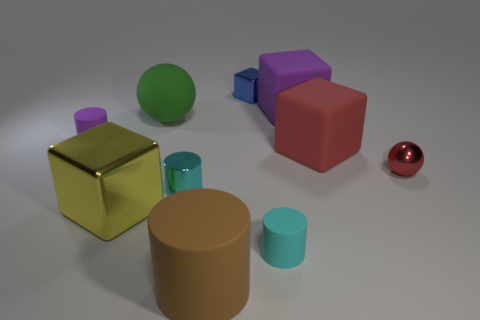What different shapes are present in this image? In this image, you can observe a variety of geometric shapes including cubes, cylinders, and spheres. Which shapes have a glossy surface? The red sphere has a glossy surface that reflects the light, giving it a shiny appearance. 